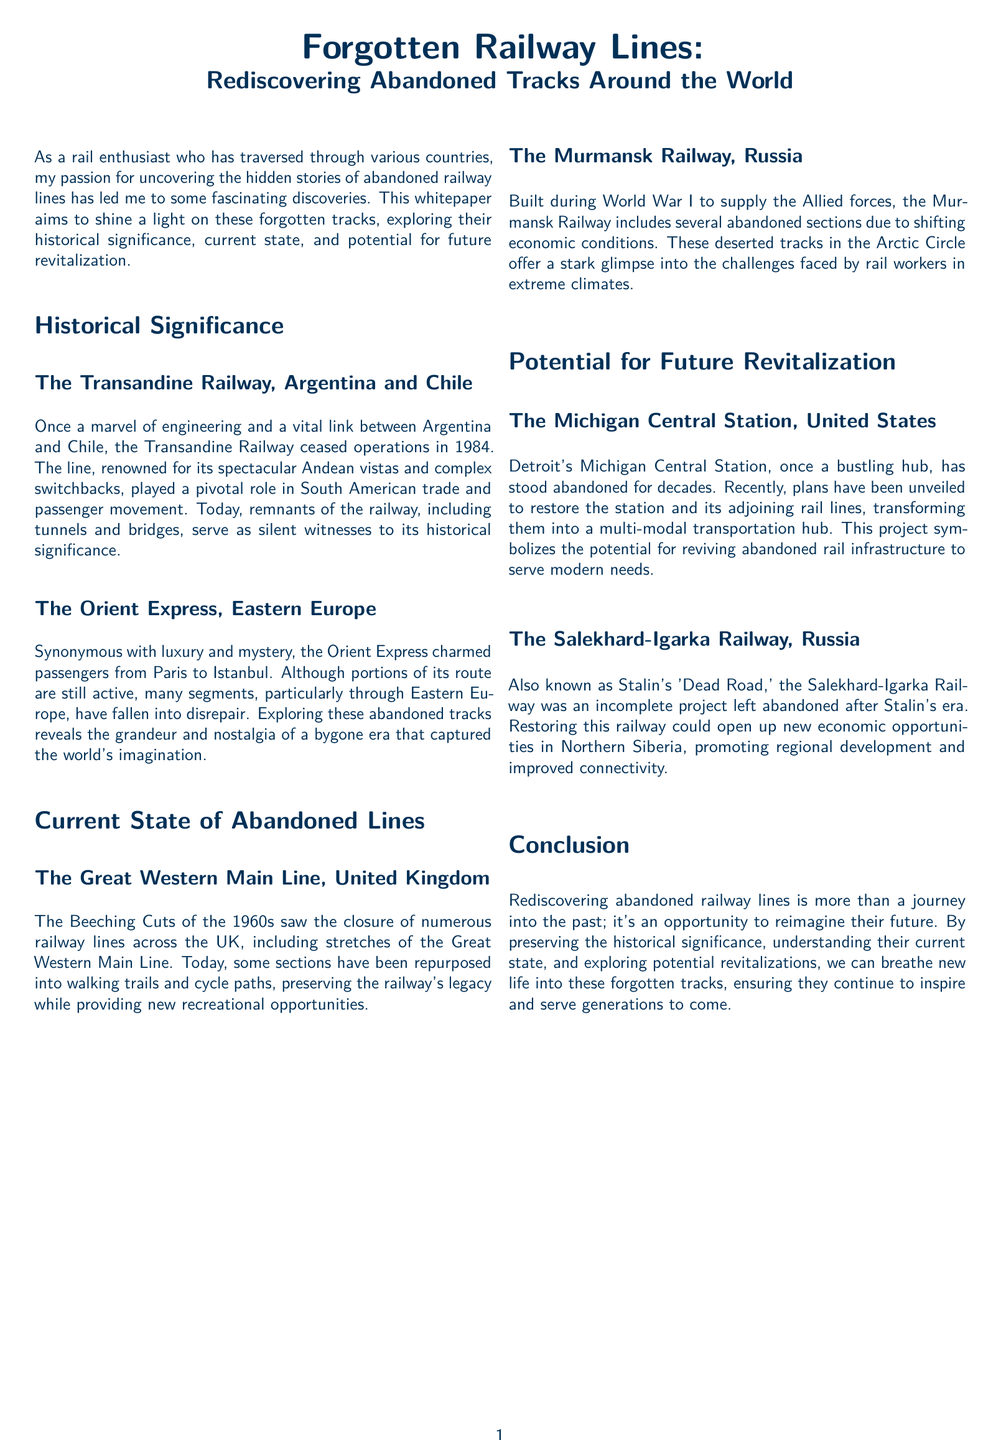What railway ceased operations in 1984? The Transandine Railway ceased operations in 1984, highlighting its historical significance.
Answer: Transandine Railway Which railway is associated with luxury and mystery? The Orient Express is synonymous with luxury and mystery, captivating passengers with its grandeur.
Answer: Orient Express What event caused closures of numerous railway lines in the UK? The Beeching Cuts of the 1960s led to the closure of numerous railway lines across the UK.
Answer: Beeching Cuts What is the potential benefit of restoring the Salekhard-Igarka Railway? Restoring the Salekhard-Igarka Railway could open up new economic opportunities in Northern Siberia.
Answer: Economic opportunities Where is the Michigan Central Station located? The Michigan Central Station is located in Detroit, symbolizing the potential for revitalizing abandoned rail infrastructure.
Answer: Detroit 